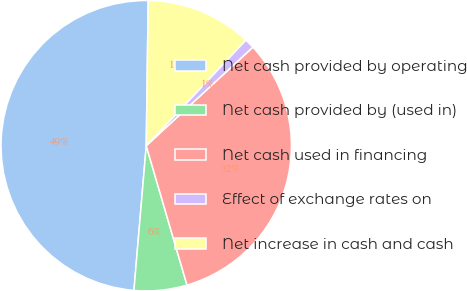Convert chart. <chart><loc_0><loc_0><loc_500><loc_500><pie_chart><fcel>Net cash provided by operating<fcel>Net cash provided by (used in)<fcel>Net cash used in financing<fcel>Effect of exchange rates on<fcel>Net increase in cash and cash<nl><fcel>48.87%<fcel>5.88%<fcel>32.35%<fcel>1.1%<fcel>11.81%<nl></chart> 